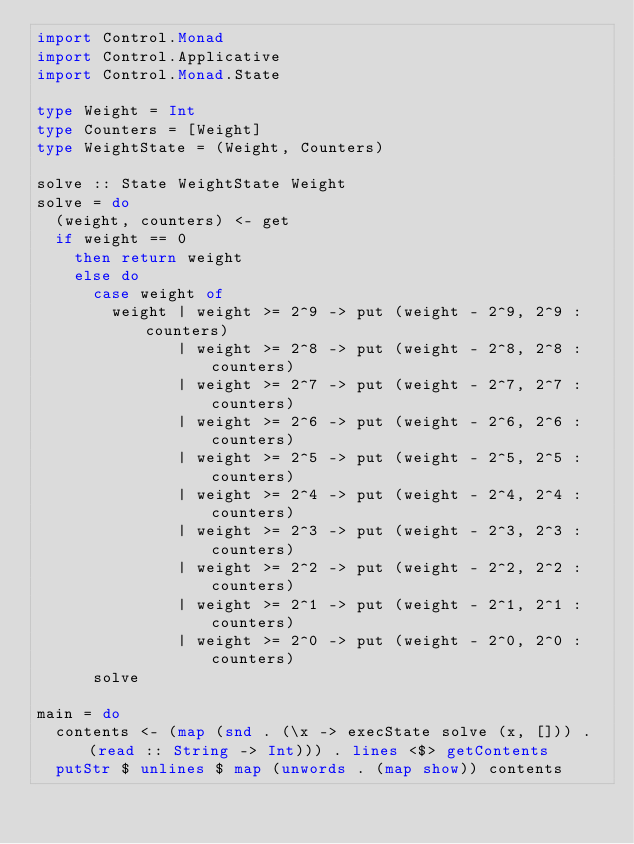<code> <loc_0><loc_0><loc_500><loc_500><_Haskell_>import Control.Monad
import Control.Applicative
import Control.Monad.State

type Weight = Int
type Counters = [Weight]
type WeightState = (Weight, Counters)

solve :: State WeightState Weight
solve = do
  (weight, counters) <- get
  if weight == 0
    then return weight
    else do
      case weight of
        weight | weight >= 2^9 -> put (weight - 2^9, 2^9 : counters)
               | weight >= 2^8 -> put (weight - 2^8, 2^8 : counters)
               | weight >= 2^7 -> put (weight - 2^7, 2^7 : counters)
               | weight >= 2^6 -> put (weight - 2^6, 2^6 : counters)
               | weight >= 2^5 -> put (weight - 2^5, 2^5 : counters)
               | weight >= 2^4 -> put (weight - 2^4, 2^4 : counters)
               | weight >= 2^3 -> put (weight - 2^3, 2^3 : counters)
               | weight >= 2^2 -> put (weight - 2^2, 2^2 : counters)
               | weight >= 2^1 -> put (weight - 2^1, 2^1 : counters)
               | weight >= 2^0 -> put (weight - 2^0, 2^0 : counters)
      solve

main = do
  contents <- (map (snd . (\x -> execState solve (x, [])) . (read :: String -> Int))) . lines <$> getContents
  putStr $ unlines $ map (unwords . (map show)) contents</code> 